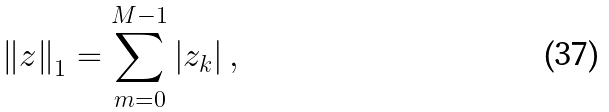Convert formula to latex. <formula><loc_0><loc_0><loc_500><loc_500>\left \| z \right \| _ { 1 } = \sum _ { m = 0 } ^ { M - 1 } \left | z _ { k } \right | ,</formula> 